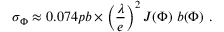<formula> <loc_0><loc_0><loc_500><loc_500>\sigma _ { \Phi } \approx 0 . 0 7 4 p b \times \left ( \frac { \lambda } { e } \right ) ^ { 2 } J ( \Phi ) b ( \Phi ) .</formula> 